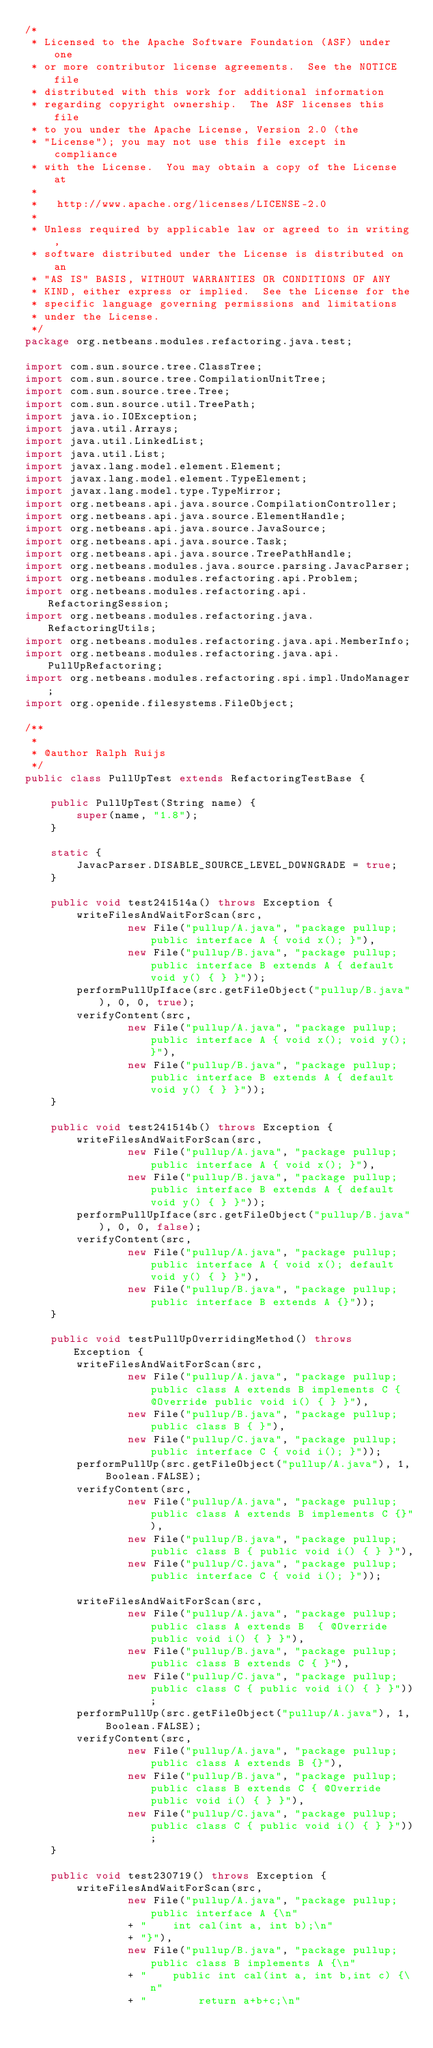Convert code to text. <code><loc_0><loc_0><loc_500><loc_500><_Java_>/*
 * Licensed to the Apache Software Foundation (ASF) under one
 * or more contributor license agreements.  See the NOTICE file
 * distributed with this work for additional information
 * regarding copyright ownership.  The ASF licenses this file
 * to you under the Apache License, Version 2.0 (the
 * "License"); you may not use this file except in compliance
 * with the License.  You may obtain a copy of the License at
 *
 *   http://www.apache.org/licenses/LICENSE-2.0
 *
 * Unless required by applicable law or agreed to in writing,
 * software distributed under the License is distributed on an
 * "AS IS" BASIS, WITHOUT WARRANTIES OR CONDITIONS OF ANY
 * KIND, either express or implied.  See the License for the
 * specific language governing permissions and limitations
 * under the License.
 */
package org.netbeans.modules.refactoring.java.test;

import com.sun.source.tree.ClassTree;
import com.sun.source.tree.CompilationUnitTree;
import com.sun.source.tree.Tree;
import com.sun.source.util.TreePath;
import java.io.IOException;
import java.util.Arrays;
import java.util.LinkedList;
import java.util.List;
import javax.lang.model.element.Element;
import javax.lang.model.element.TypeElement;
import javax.lang.model.type.TypeMirror;
import org.netbeans.api.java.source.CompilationController;
import org.netbeans.api.java.source.ElementHandle;
import org.netbeans.api.java.source.JavaSource;
import org.netbeans.api.java.source.Task;
import org.netbeans.api.java.source.TreePathHandle;
import org.netbeans.modules.java.source.parsing.JavacParser;
import org.netbeans.modules.refactoring.api.Problem;
import org.netbeans.modules.refactoring.api.RefactoringSession;
import org.netbeans.modules.refactoring.java.RefactoringUtils;
import org.netbeans.modules.refactoring.java.api.MemberInfo;
import org.netbeans.modules.refactoring.java.api.PullUpRefactoring;
import org.netbeans.modules.refactoring.spi.impl.UndoManager;
import org.openide.filesystems.FileObject;

/**
 *
 * @author Ralph Ruijs
 */
public class PullUpTest extends RefactoringTestBase {

    public PullUpTest(String name) {
        super(name, "1.8");
    }
    
    static {
        JavacParser.DISABLE_SOURCE_LEVEL_DOWNGRADE = true;
    }
    
    public void test241514a() throws Exception {
        writeFilesAndWaitForScan(src,
                new File("pullup/A.java", "package pullup; public interface A { void x(); }"),
                new File("pullup/B.java", "package pullup; public interface B extends A { default void y() { } }"));
        performPullUpIface(src.getFileObject("pullup/B.java"), 0, 0, true);
        verifyContent(src,
                new File("pullup/A.java", "package pullup; public interface A { void x(); void y(); }"),
                new File("pullup/B.java", "package pullup; public interface B extends A { default void y() { } }"));
    }
    
    public void test241514b() throws Exception {
        writeFilesAndWaitForScan(src,
                new File("pullup/A.java", "package pullup; public interface A { void x(); }"),
                new File("pullup/B.java", "package pullup; public interface B extends A { default void y() { } }"));
        performPullUpIface(src.getFileObject("pullup/B.java"), 0, 0, false);
        verifyContent(src,
                new File("pullup/A.java", "package pullup; public interface A { void x(); default void y() { } }"),
                new File("pullup/B.java", "package pullup; public interface B extends A {}"));
    }
    
    public void testPullUpOverridingMethod() throws Exception {
        writeFilesAndWaitForScan(src,
                new File("pullup/A.java", "package pullup; public class A extends B implements C { @Override public void i() { } }"),
                new File("pullup/B.java", "package pullup; public class B { }"),
                new File("pullup/C.java", "package pullup; public interface C { void i(); }"));
        performPullUp(src.getFileObject("pullup/A.java"), 1, Boolean.FALSE);
        verifyContent(src,
                new File("pullup/A.java", "package pullup; public class A extends B implements C {}"),
                new File("pullup/B.java", "package pullup; public class B { public void i() { } }"),
                new File("pullup/C.java", "package pullup; public interface C { void i(); }"));
        
        writeFilesAndWaitForScan(src,
                new File("pullup/A.java", "package pullup; public class A extends B  { @Override public void i() { } }"),
                new File("pullup/B.java", "package pullup; public class B extends C { }"),
                new File("pullup/C.java", "package pullup; public class C { public void i() { } }"));
        performPullUp(src.getFileObject("pullup/A.java"), 1, Boolean.FALSE);
        verifyContent(src,
                new File("pullup/A.java", "package pullup; public class A extends B {}"),
                new File("pullup/B.java", "package pullup; public class B extends C { @Override public void i() { } }"),
                new File("pullup/C.java", "package pullup; public class C { public void i() { } }"));
    }
    
    public void test230719() throws Exception {
        writeFilesAndWaitForScan(src,
                new File("pullup/A.java", "package pullup; public interface A {\n"
                + "    int cal(int a, int b);\n"
                + "}"),
                new File("pullup/B.java", "package pullup; public class B implements A {\n"
                + "    public int cal(int a, int b,int c) {\n"
                + "        return a+b+c;\n"</code> 